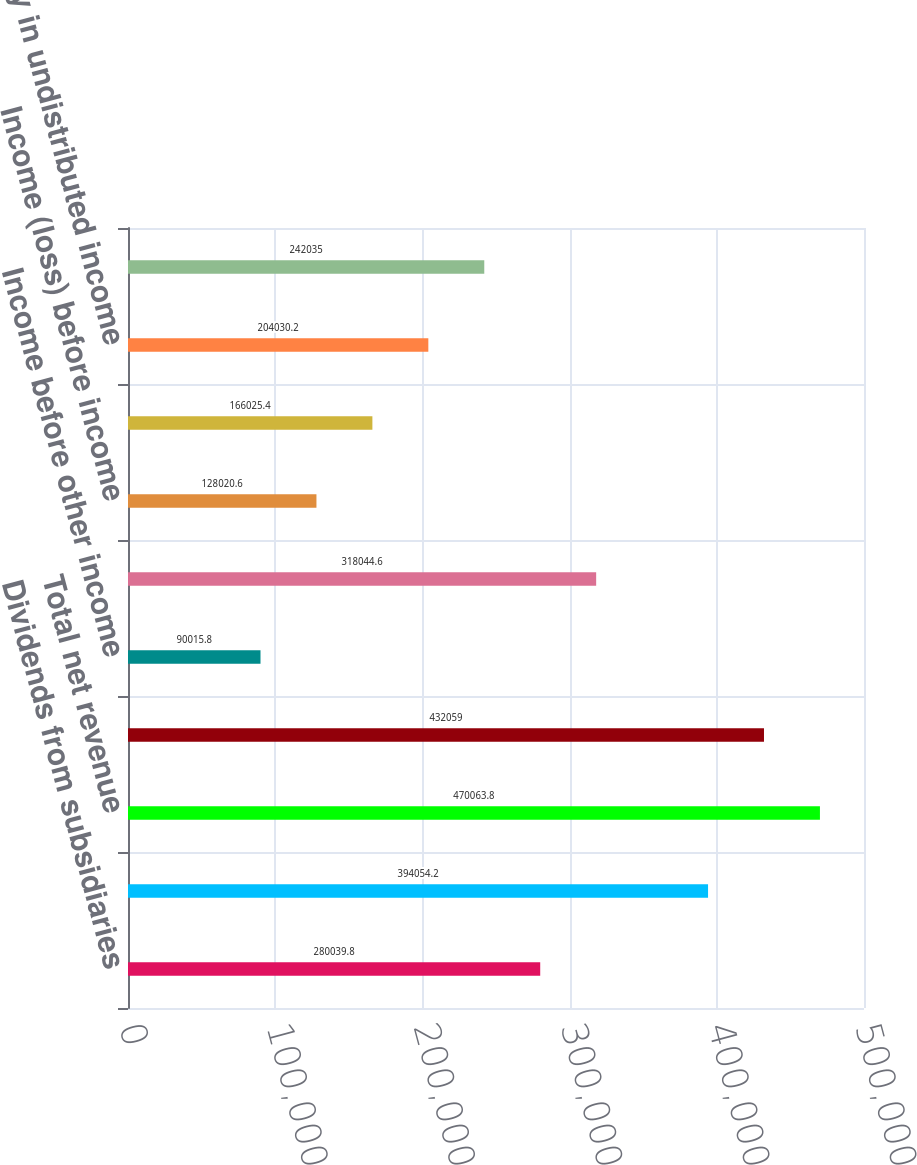<chart> <loc_0><loc_0><loc_500><loc_500><bar_chart><fcel>Dividends from subsidiaries<fcel>Other revenues<fcel>Total net revenue<fcel>Total operating expense<fcel>Income before other income<fcel>Total other income (expense)<fcel>Income (loss) before income<fcel>Income tax benefit<fcel>Equity in undistributed income<fcel>Net income (loss)<nl><fcel>280040<fcel>394054<fcel>470064<fcel>432059<fcel>90015.8<fcel>318045<fcel>128021<fcel>166025<fcel>204030<fcel>242035<nl></chart> 